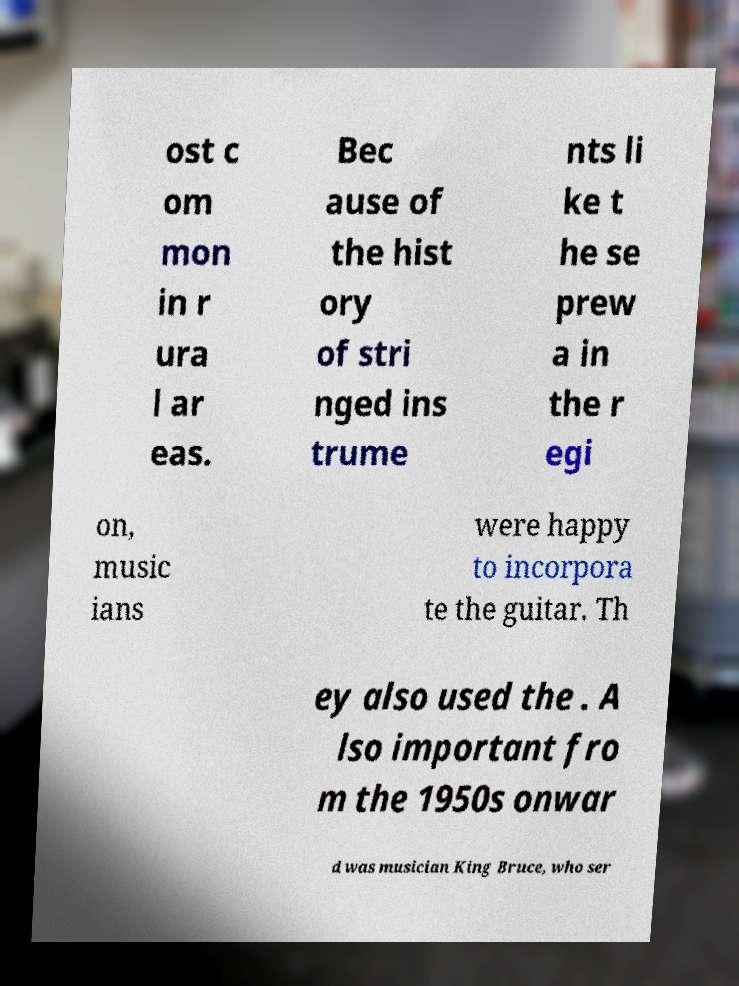Could you assist in decoding the text presented in this image and type it out clearly? ost c om mon in r ura l ar eas. Bec ause of the hist ory of stri nged ins trume nts li ke t he se prew a in the r egi on, music ians were happy to incorpora te the guitar. Th ey also used the . A lso important fro m the 1950s onwar d was musician King Bruce, who ser 